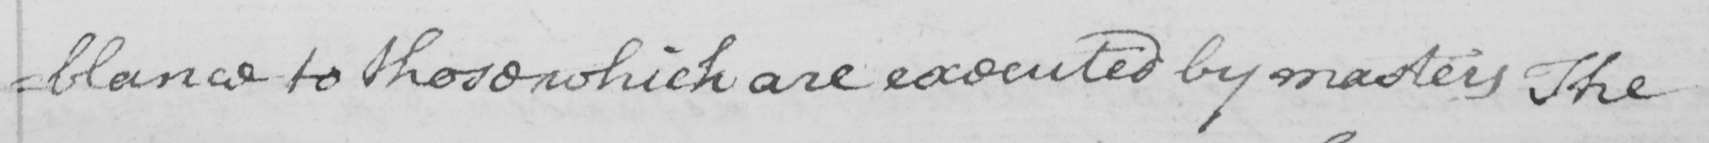What text is written in this handwritten line? =blance to those which are executed by masters The 